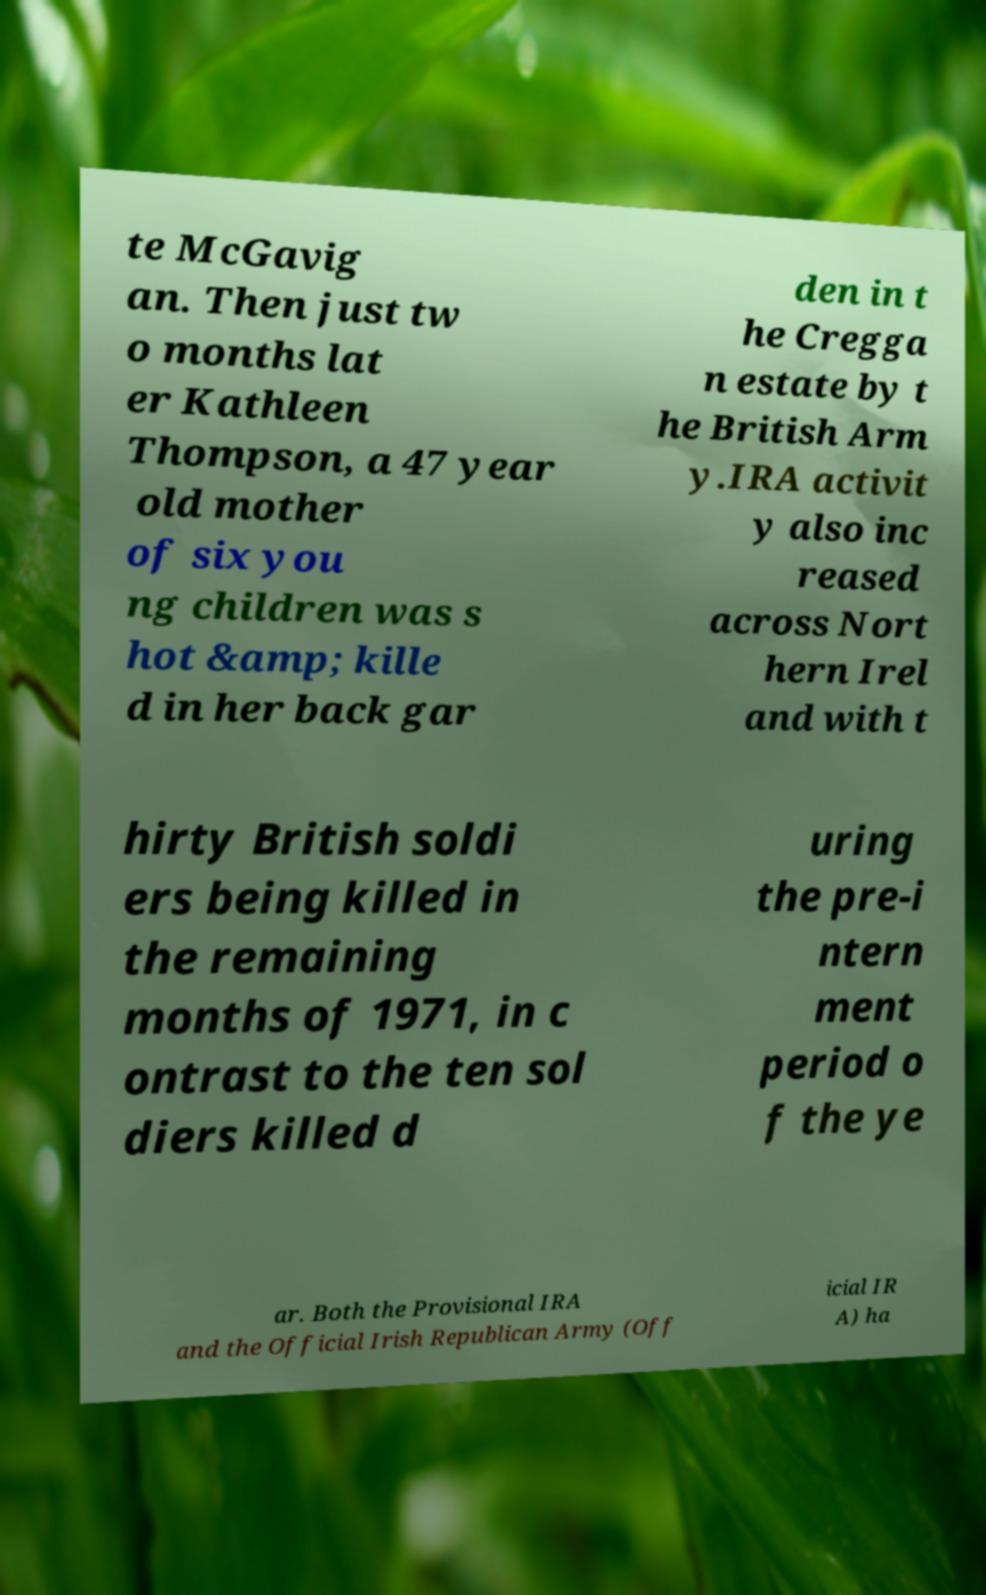Could you extract and type out the text from this image? te McGavig an. Then just tw o months lat er Kathleen Thompson, a 47 year old mother of six you ng children was s hot &amp; kille d in her back gar den in t he Cregga n estate by t he British Arm y.IRA activit y also inc reased across Nort hern Irel and with t hirty British soldi ers being killed in the remaining months of 1971, in c ontrast to the ten sol diers killed d uring the pre-i ntern ment period o f the ye ar. Both the Provisional IRA and the Official Irish Republican Army (Off icial IR A) ha 